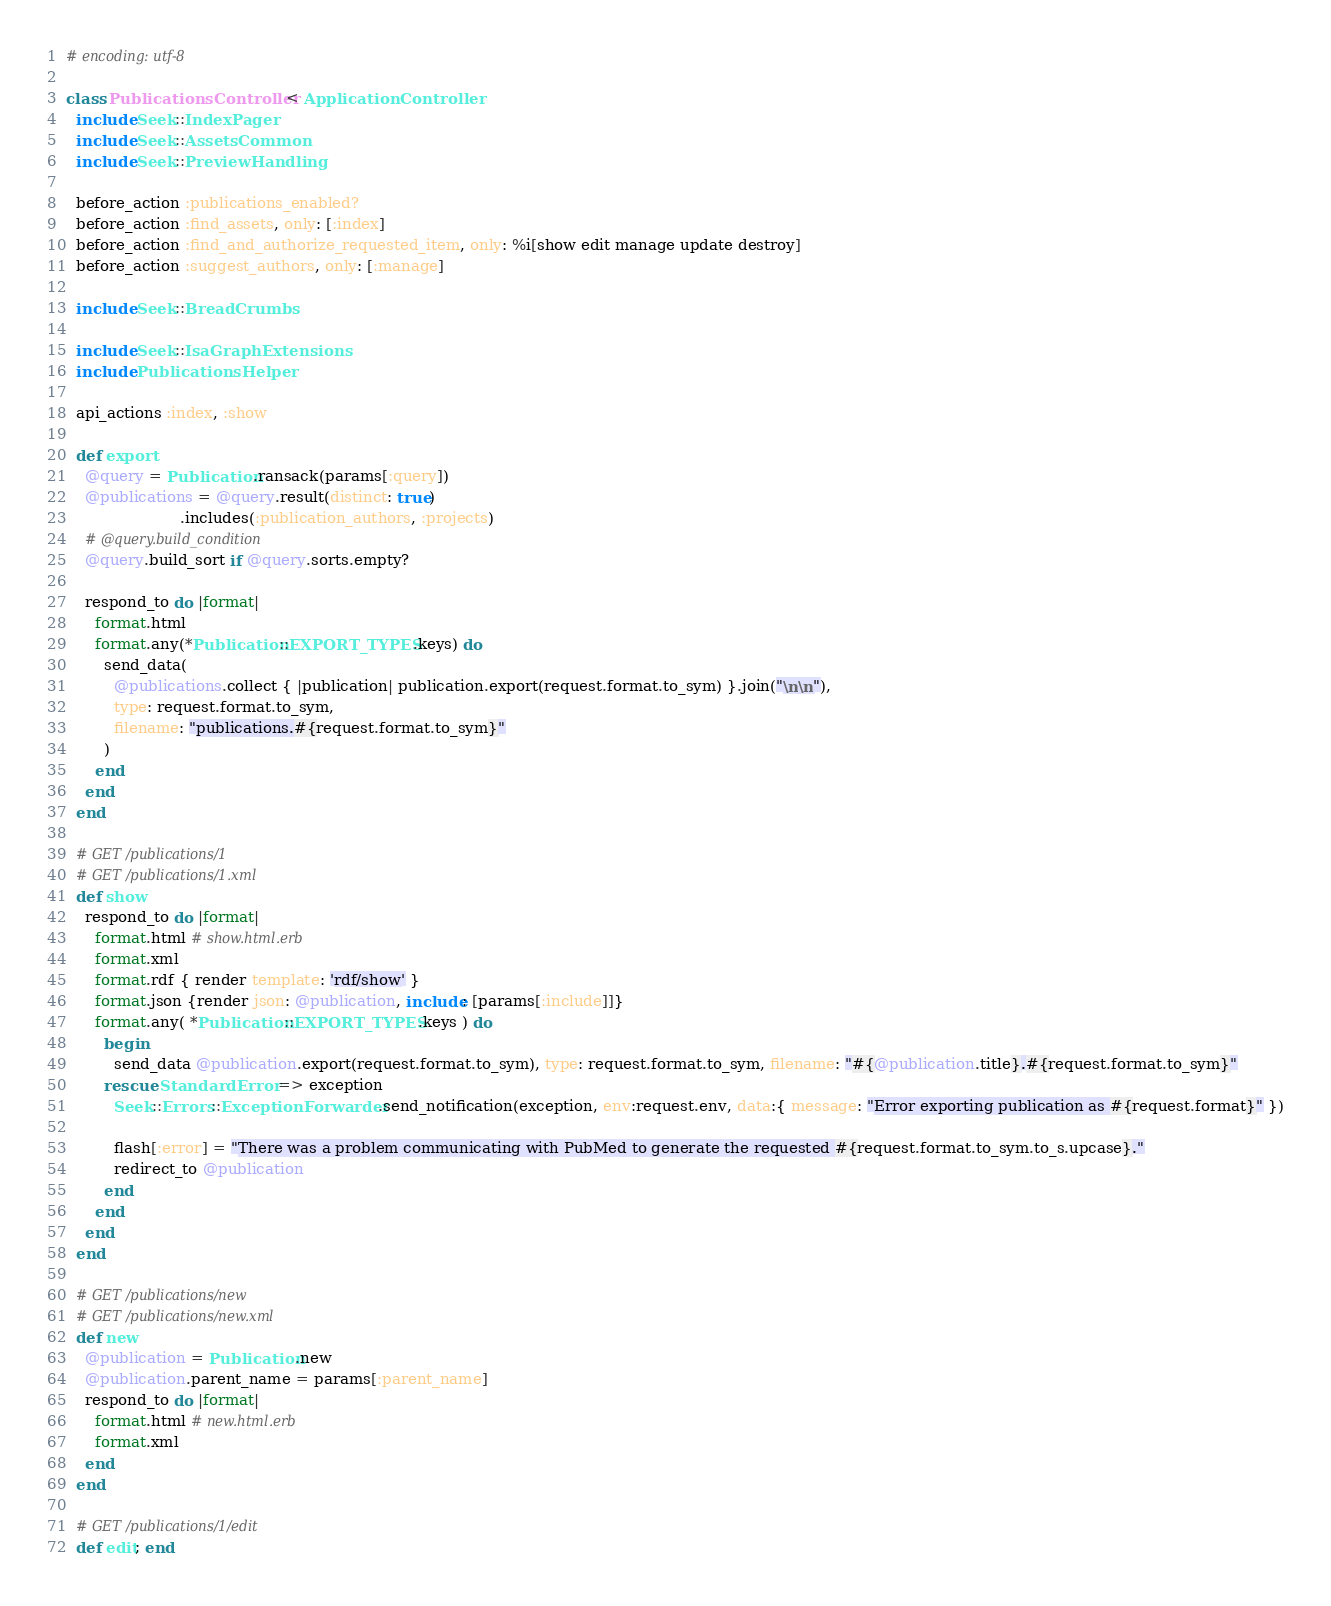<code> <loc_0><loc_0><loc_500><loc_500><_Ruby_># encoding: utf-8

class PublicationsController < ApplicationController
  include Seek::IndexPager
  include Seek::AssetsCommon
  include Seek::PreviewHandling

  before_action :publications_enabled?
  before_action :find_assets, only: [:index]
  before_action :find_and_authorize_requested_item, only: %i[show edit manage update destroy]
  before_action :suggest_authors, only: [:manage]

  include Seek::BreadCrumbs

  include Seek::IsaGraphExtensions
  include PublicationsHelper

  api_actions :index, :show

  def export
    @query = Publication.ransack(params[:query])
    @publications = @query.result(distinct: true)
                        .includes(:publication_authors, :projects)
    # @query.build_condition
    @query.build_sort if @query.sorts.empty?

    respond_to do |format|
      format.html
      format.any(*Publication::EXPORT_TYPES.keys) do
        send_data(
          @publications.collect { |publication| publication.export(request.format.to_sym) }.join("\n\n"),
          type: request.format.to_sym,
          filename: "publications.#{request.format.to_sym}"
        )
      end
    end
  end

  # GET /publications/1
  # GET /publications/1.xml
  def show
    respond_to do |format|
      format.html # show.html.erb
      format.xml
      format.rdf { render template: 'rdf/show' }
      format.json {render json: @publication, include: [params[:include]]}
      format.any( *Publication::EXPORT_TYPES.keys ) do
        begin
          send_data @publication.export(request.format.to_sym), type: request.format.to_sym, filename: "#{@publication.title}.#{request.format.to_sym}"
        rescue StandardError => exception
          Seek::Errors::ExceptionForwarder.send_notification(exception, env:request.env, data:{ message: "Error exporting publication as #{request.format}" })

          flash[:error] = "There was a problem communicating with PubMed to generate the requested #{request.format.to_sym.to_s.upcase}."
          redirect_to @publication
        end
      end
    end
  end

  # GET /publications/new
  # GET /publications/new.xml
  def new
    @publication = Publication.new
    @publication.parent_name = params[:parent_name]
    respond_to do |format|
      format.html # new.html.erb
      format.xml
    end
  end

  # GET /publications/1/edit
  def edit; end
</code> 